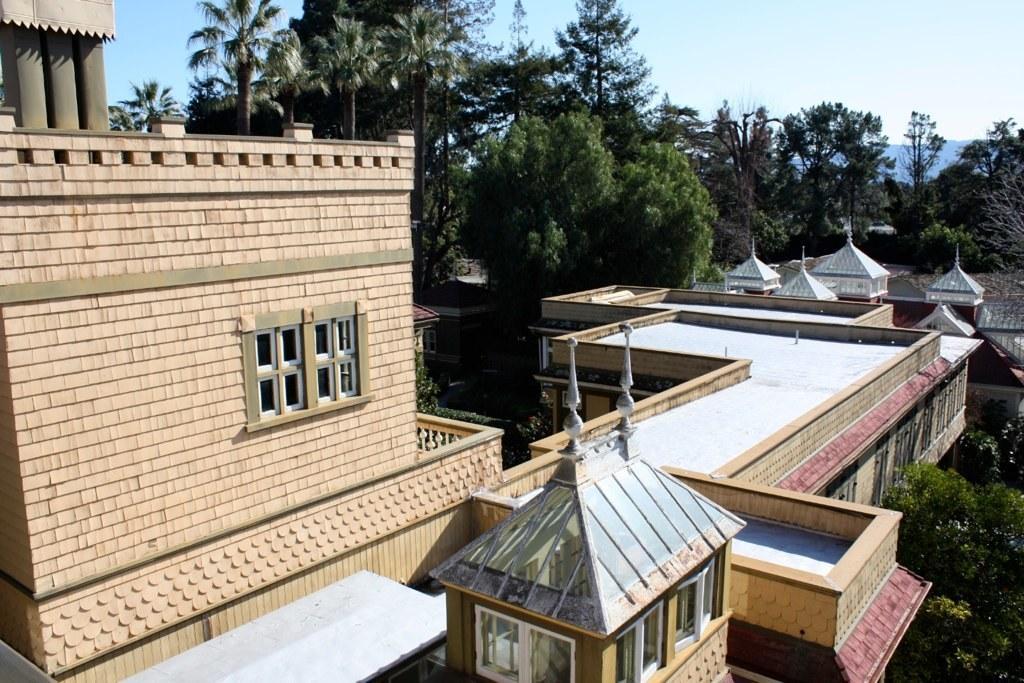Can you describe this image briefly? In this image, we can see building and some trees. There is a sky at the top of the image. 